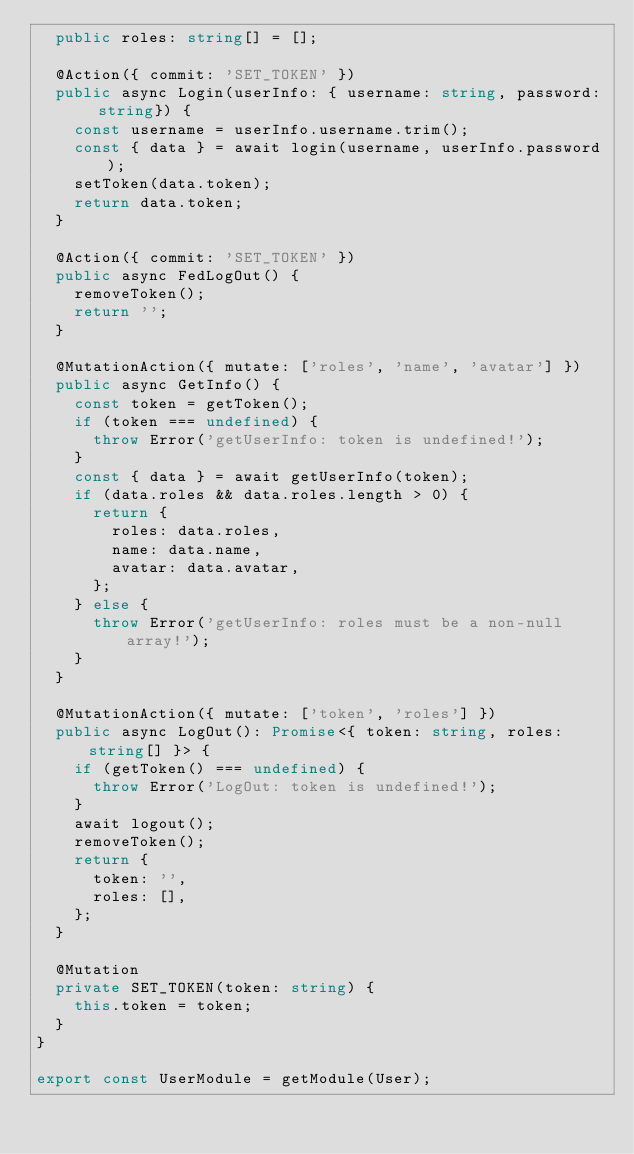<code> <loc_0><loc_0><loc_500><loc_500><_TypeScript_>  public roles: string[] = [];

  @Action({ commit: 'SET_TOKEN' })
  public async Login(userInfo: { username: string, password: string}) {
    const username = userInfo.username.trim();
    const { data } = await login(username, userInfo.password);
    setToken(data.token);
    return data.token;
  }

  @Action({ commit: 'SET_TOKEN' })
  public async FedLogOut() {
    removeToken();
    return '';
  }

  @MutationAction({ mutate: ['roles', 'name', 'avatar'] })
  public async GetInfo() {
    const token = getToken();
    if (token === undefined) {
      throw Error('getUserInfo: token is undefined!');
    }
    const { data } = await getUserInfo(token);
    if (data.roles && data.roles.length > 0) {
      return {
        roles: data.roles,
        name: data.name,
        avatar: data.avatar,
      };
    } else {
      throw Error('getUserInfo: roles must be a non-null array!');
    }
  }

  @MutationAction({ mutate: ['token', 'roles'] })
  public async LogOut(): Promise<{ token: string, roles: string[] }> {
    if (getToken() === undefined) {
      throw Error('LogOut: token is undefined!');
    }
    await logout();
    removeToken();
    return {
      token: '',
      roles: [],
    };
  }

  @Mutation
  private SET_TOKEN(token: string) {
    this.token = token;
  }
}

export const UserModule = getModule(User);
</code> 